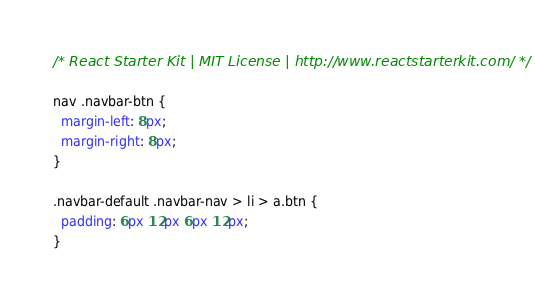<code> <loc_0><loc_0><loc_500><loc_500><_CSS_>/* React Starter Kit | MIT License | http://www.reactstarterkit.com/ */

nav .navbar-btn {
  margin-left: 8px;
  margin-right: 8px;
}

.navbar-default .navbar-nav > li > a.btn {
  padding: 6px 12px 6px 12px;
}
</code> 